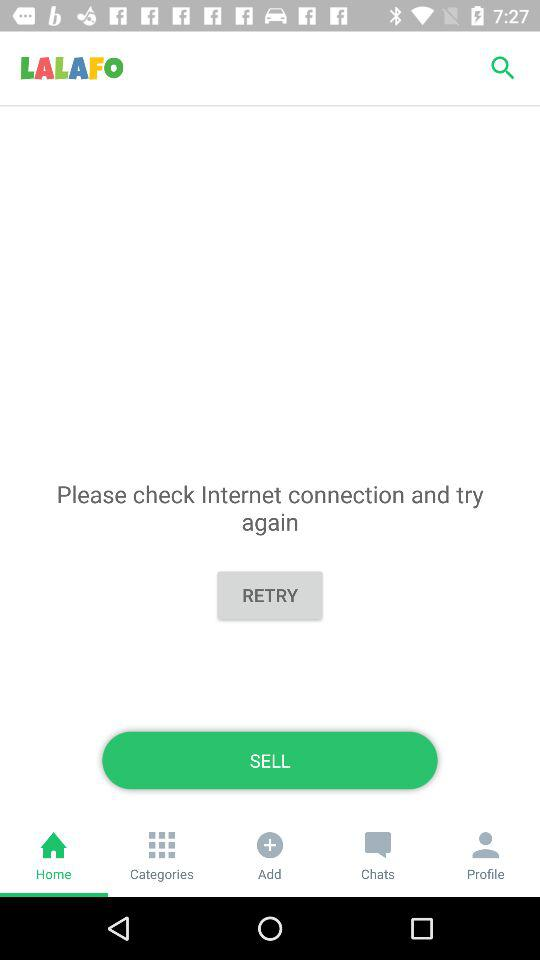Which tab is selected? The selected tab is "Home". 